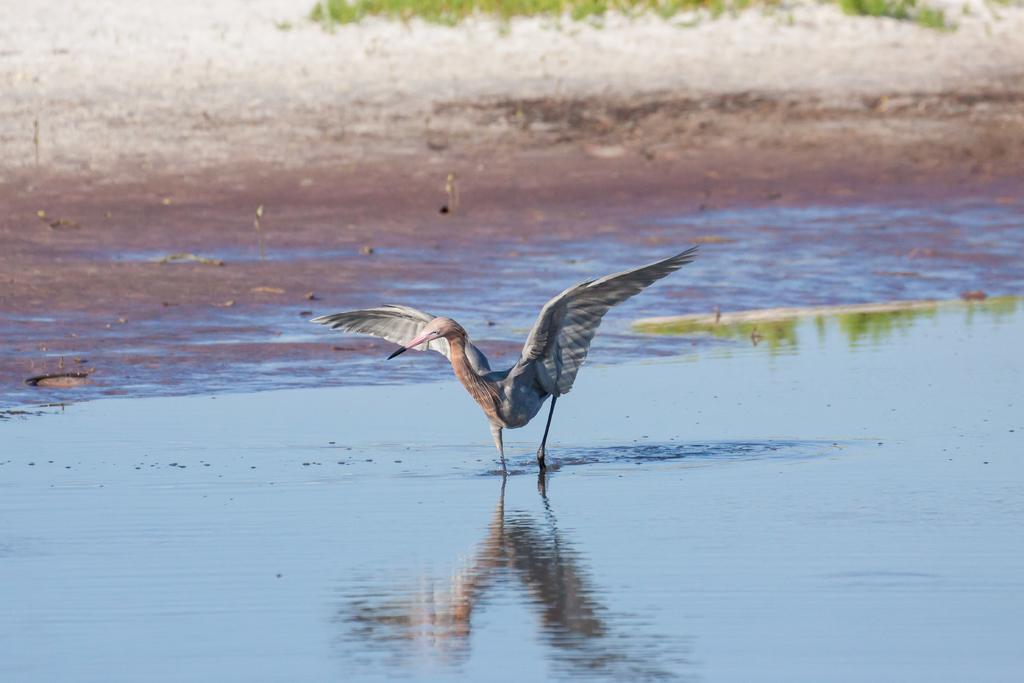What is present at the bottom of the image? There is water at the bottom of the image. What can be seen in the middle of the image? There is a bird in the middle of the image. What type of protest is happening in the image? There is no protest present in the image; it features water and a bird. What type of desk can be seen in the image? There is no desk present in the image. 